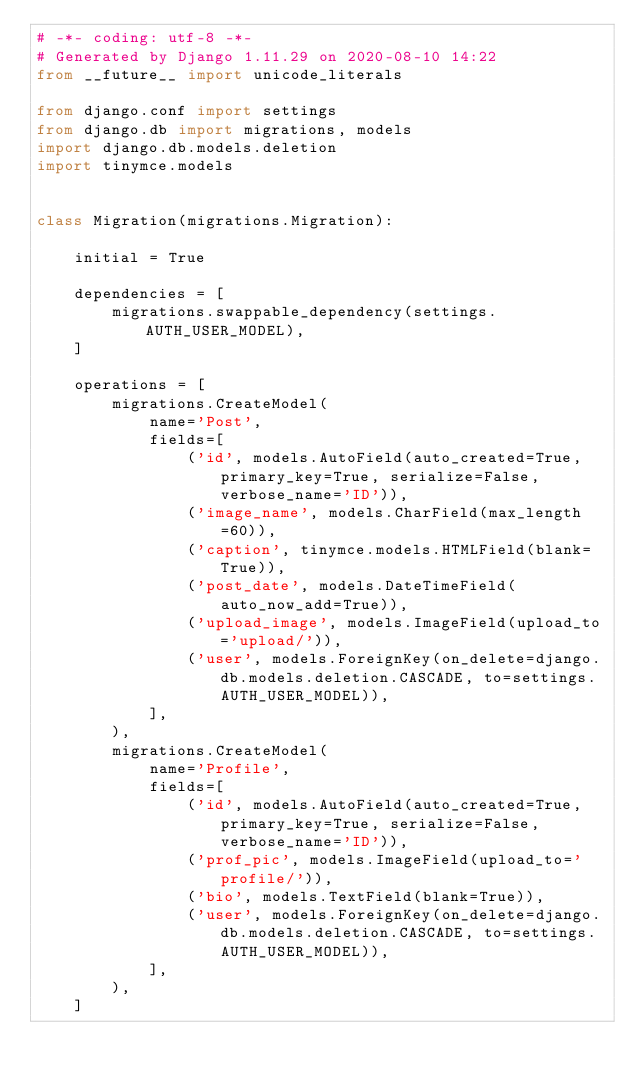Convert code to text. <code><loc_0><loc_0><loc_500><loc_500><_Python_># -*- coding: utf-8 -*-
# Generated by Django 1.11.29 on 2020-08-10 14:22
from __future__ import unicode_literals

from django.conf import settings
from django.db import migrations, models
import django.db.models.deletion
import tinymce.models


class Migration(migrations.Migration):

    initial = True

    dependencies = [
        migrations.swappable_dependency(settings.AUTH_USER_MODEL),
    ]

    operations = [
        migrations.CreateModel(
            name='Post',
            fields=[
                ('id', models.AutoField(auto_created=True, primary_key=True, serialize=False, verbose_name='ID')),
                ('image_name', models.CharField(max_length=60)),
                ('caption', tinymce.models.HTMLField(blank=True)),
                ('post_date', models.DateTimeField(auto_now_add=True)),
                ('upload_image', models.ImageField(upload_to='upload/')),
                ('user', models.ForeignKey(on_delete=django.db.models.deletion.CASCADE, to=settings.AUTH_USER_MODEL)),
            ],
        ),
        migrations.CreateModel(
            name='Profile',
            fields=[
                ('id', models.AutoField(auto_created=True, primary_key=True, serialize=False, verbose_name='ID')),
                ('prof_pic', models.ImageField(upload_to='profile/')),
                ('bio', models.TextField(blank=True)),
                ('user', models.ForeignKey(on_delete=django.db.models.deletion.CASCADE, to=settings.AUTH_USER_MODEL)),
            ],
        ),
    ]
</code> 